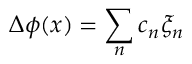<formula> <loc_0><loc_0><loc_500><loc_500>\Delta \phi ( x ) = \sum _ { n } c _ { n } \xi _ { n }</formula> 